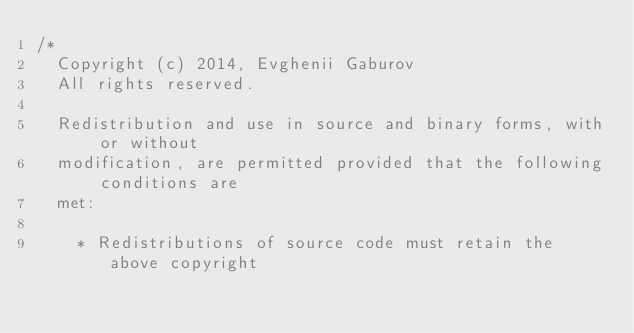Convert code to text. <code><loc_0><loc_0><loc_500><loc_500><_Cuda_>/*
  Copyright (c) 2014, Evghenii Gaburov
  All rights reserved.

  Redistribution and use in source and binary forms, with or without
  modification, are permitted provided that the following conditions are
  met:

    * Redistributions of source code must retain the above copyright</code> 